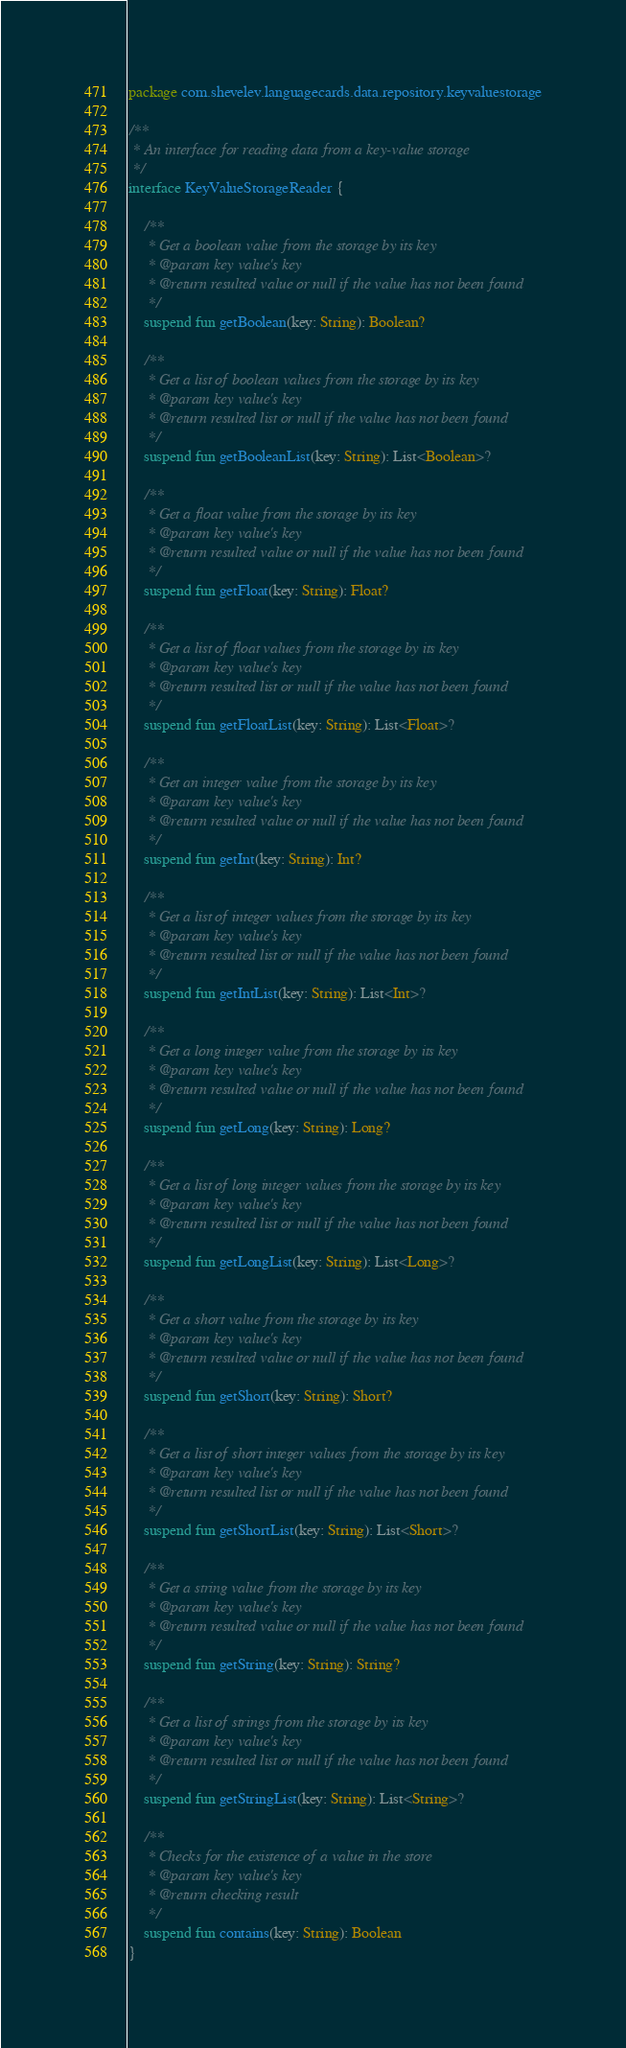<code> <loc_0><loc_0><loc_500><loc_500><_Kotlin_>package com.shevelev.languagecards.data.repository.keyvaluestorage

/**
 * An interface for reading data from a key-value storage
 */
interface KeyValueStorageReader {

    /**
     * Get a boolean value from the storage by its key
     * @param key value's key
     * @return resulted value or null if the value has not been found
     */
    suspend fun getBoolean(key: String): Boolean?

    /**
     * Get a list of boolean values from the storage by its key
     * @param key value's key
     * @return resulted list or null if the value has not been found
     */
    suspend fun getBooleanList(key: String): List<Boolean>?

    /**
     * Get a float value from the storage by its key
     * @param key value's key
     * @return resulted value or null if the value has not been found
     */
    suspend fun getFloat(key: String): Float?

    /**
     * Get a list of float values from the storage by its key
     * @param key value's key
     * @return resulted list or null if the value has not been found
     */
    suspend fun getFloatList(key: String): List<Float>?

    /**
     * Get an integer value from the storage by its key
     * @param key value's key
     * @return resulted value or null if the value has not been found
     */
    suspend fun getInt(key: String): Int?

    /**
     * Get a list of integer values from the storage by its key
     * @param key value's key
     * @return resulted list or null if the value has not been found
     */
    suspend fun getIntList(key: String): List<Int>?

    /**
     * Get a long integer value from the storage by its key
     * @param key value's key
     * @return resulted value or null if the value has not been found
     */
    suspend fun getLong(key: String): Long?

    /**
     * Get a list of long integer values from the storage by its key
     * @param key value's key
     * @return resulted list or null if the value has not been found
     */
    suspend fun getLongList(key: String): List<Long>?

    /**
     * Get a short value from the storage by its key
     * @param key value's key
     * @return resulted value or null if the value has not been found
     */
    suspend fun getShort(key: String): Short?

    /**
     * Get a list of short integer values from the storage by its key
     * @param key value's key
     * @return resulted list or null if the value has not been found
     */
    suspend fun getShortList(key: String): List<Short>?

    /**
     * Get a string value from the storage by its key
     * @param key value's key
     * @return resulted value or null if the value has not been found
     */
    suspend fun getString(key: String): String?

    /**
     * Get a list of strings from the storage by its key
     * @param key value's key
     * @return resulted list or null if the value has not been found
     */
    suspend fun getStringList(key: String): List<String>?

    /**
     * Checks for the existence of a value in the store
     * @param key value's key
     * @return checking result
     */
    suspend fun contains(key: String): Boolean
}</code> 